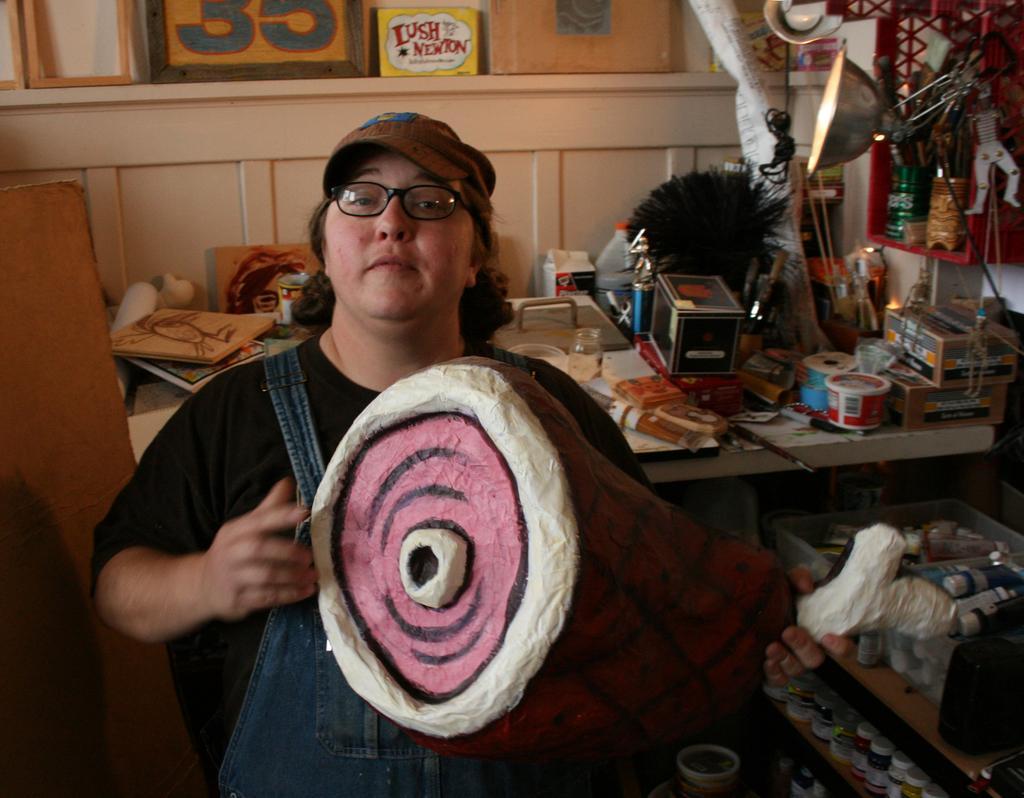Please provide a concise description of this image. This is an inside view. Here I can see a person holding an object in the hands and looking at the picture. At the back of this person there is a table on which few boxes, books, bottles and many other objects are placed. On the left side there is a wooden plank. On the right side there are few racks in which bottles are arranged. In the top right-hand corner there is a lamp. In the background there is a wall. 